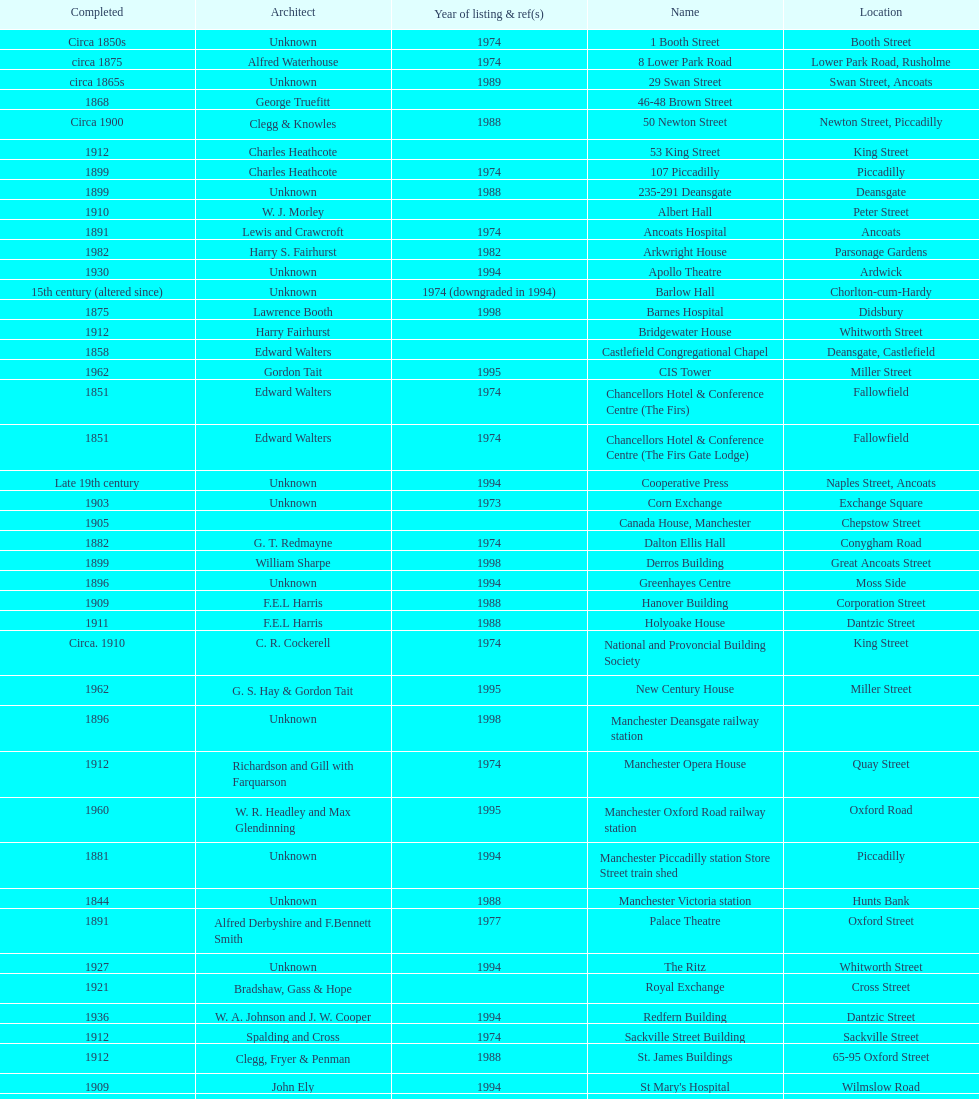Was charles heathcote the architect of ancoats hospital and apollo theatre? No. 